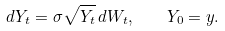<formula> <loc_0><loc_0><loc_500><loc_500>d Y _ { t } = \sigma \sqrt { Y _ { t } } \, d W _ { t } , \quad Y _ { 0 } = y .</formula> 